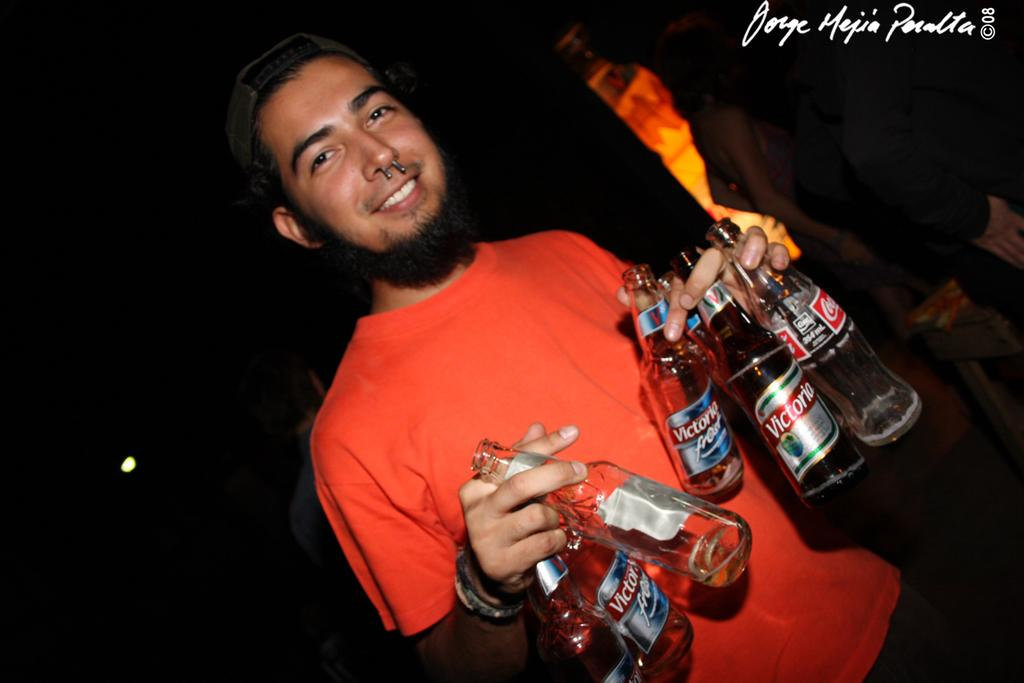What is the main subject of the image? There is a man standing in the image. What is the man holding in his hand? The man is holding bottles in his hand. Are there any other people in the image? Yes, there is another person standing in the image. How many chickens can be seen in the image? There are no chickens present in the image. Is there a fire visible in the image? There is no fire visible in the image. 